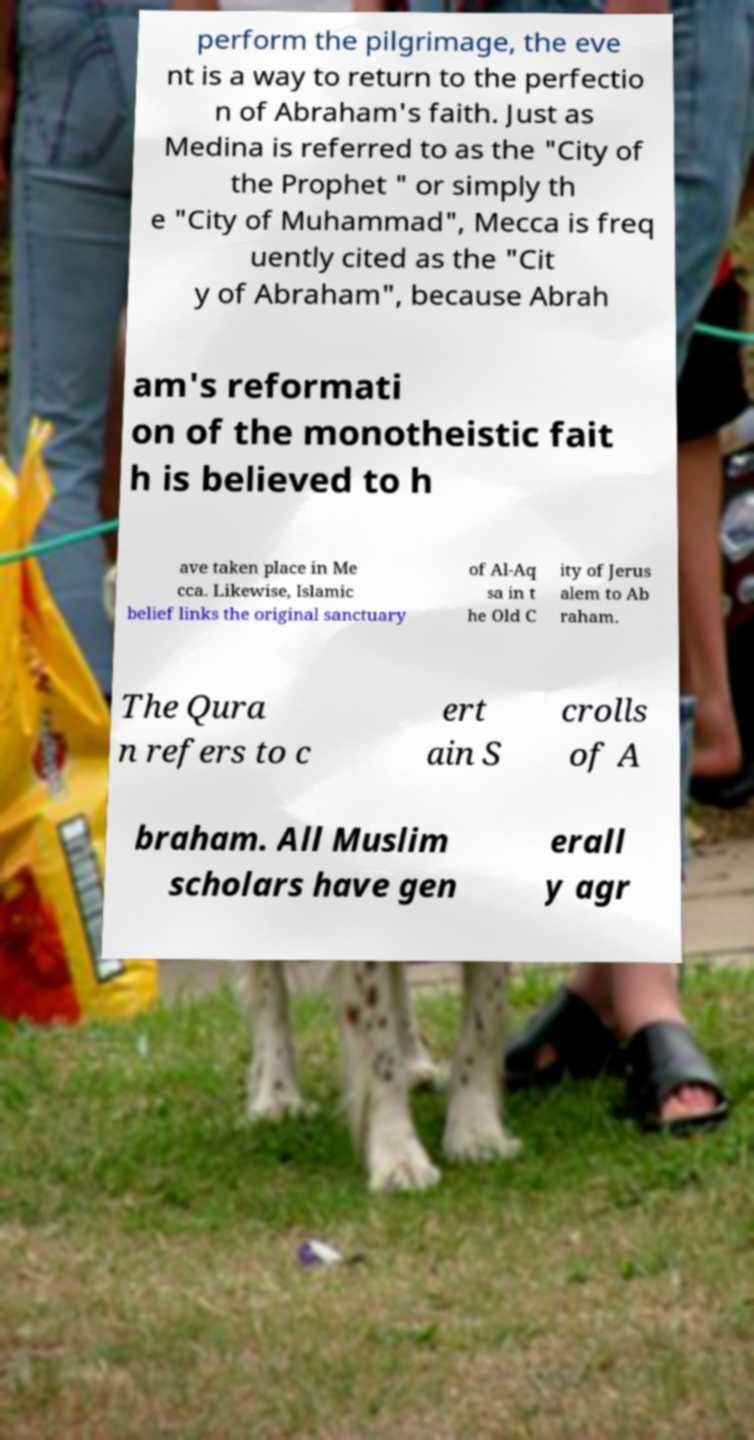Can you read and provide the text displayed in the image?This photo seems to have some interesting text. Can you extract and type it out for me? perform the pilgrimage, the eve nt is a way to return to the perfectio n of Abraham's faith. Just as Medina is referred to as the "City of the Prophet " or simply th e "City of Muhammad", Mecca is freq uently cited as the "Cit y of Abraham", because Abrah am's reformati on of the monotheistic fait h is believed to h ave taken place in Me cca. Likewise, Islamic belief links the original sanctuary of Al-Aq sa in t he Old C ity of Jerus alem to Ab raham. The Qura n refers to c ert ain S crolls of A braham. All Muslim scholars have gen erall y agr 